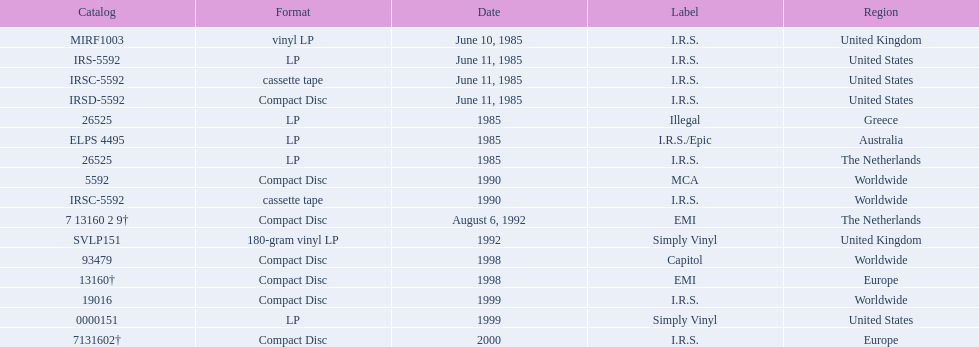In which regions was the fables of the reconstruction album released? United Kingdom, United States, United States, United States, Greece, Australia, The Netherlands, Worldwide, Worldwide, The Netherlands, United Kingdom, Worldwide, Europe, Worldwide, United States, Europe. And what were the release dates for those regions? June 10, 1985, June 11, 1985, June 11, 1985, June 11, 1985, 1985, 1985, 1985, 1990, 1990, August 6, 1992, 1992, 1998, 1998, 1999, 1999, 2000. And which region was listed after greece in 1985? Australia. 